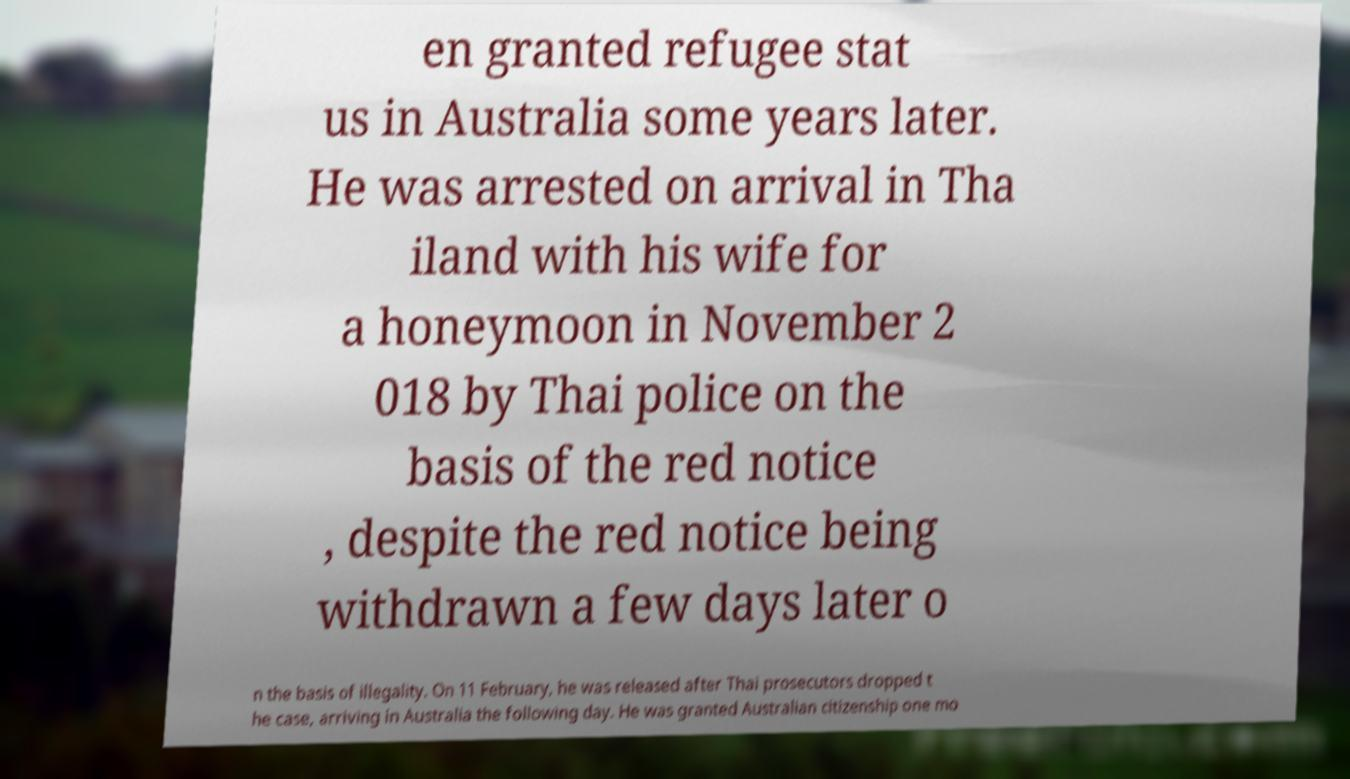Please identify and transcribe the text found in this image. en granted refugee stat us in Australia some years later. He was arrested on arrival in Tha iland with his wife for a honeymoon in November 2 018 by Thai police on the basis of the red notice , despite the red notice being withdrawn a few days later o n the basis of illegality. On 11 February, he was released after Thai prosecutors dropped t he case, arriving in Australia the following day. He was granted Australian citizenship one mo 